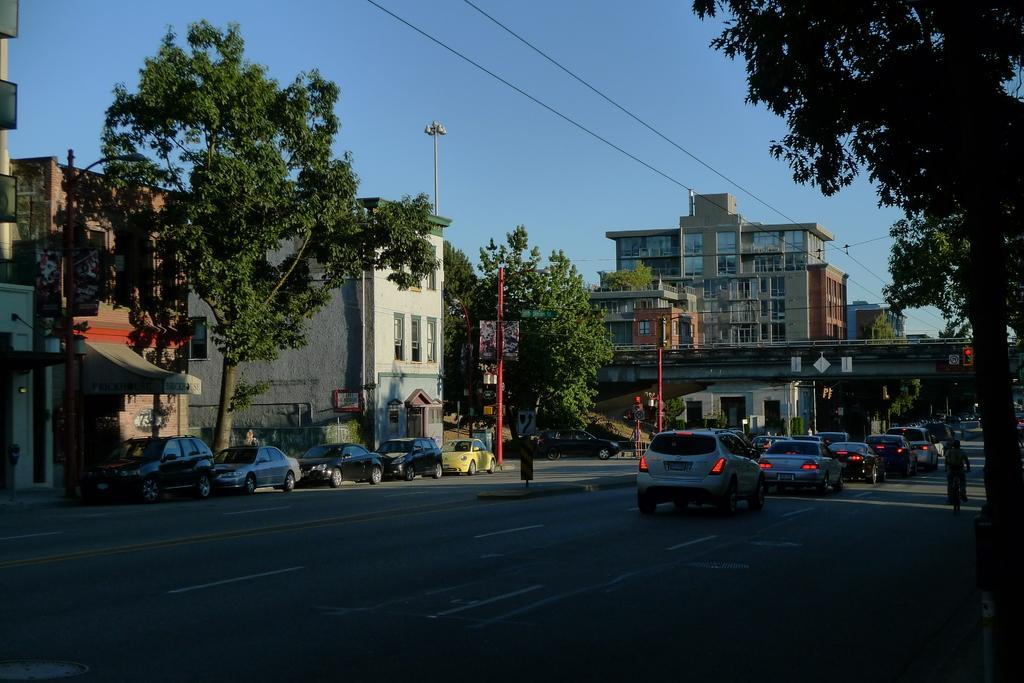Describe this image in one or two sentences. In this image we can see some vehicles on the road and there is a person riding a bicycle and we can see a bridge over the road. There are some building and trees and at the top we can see the sky. 